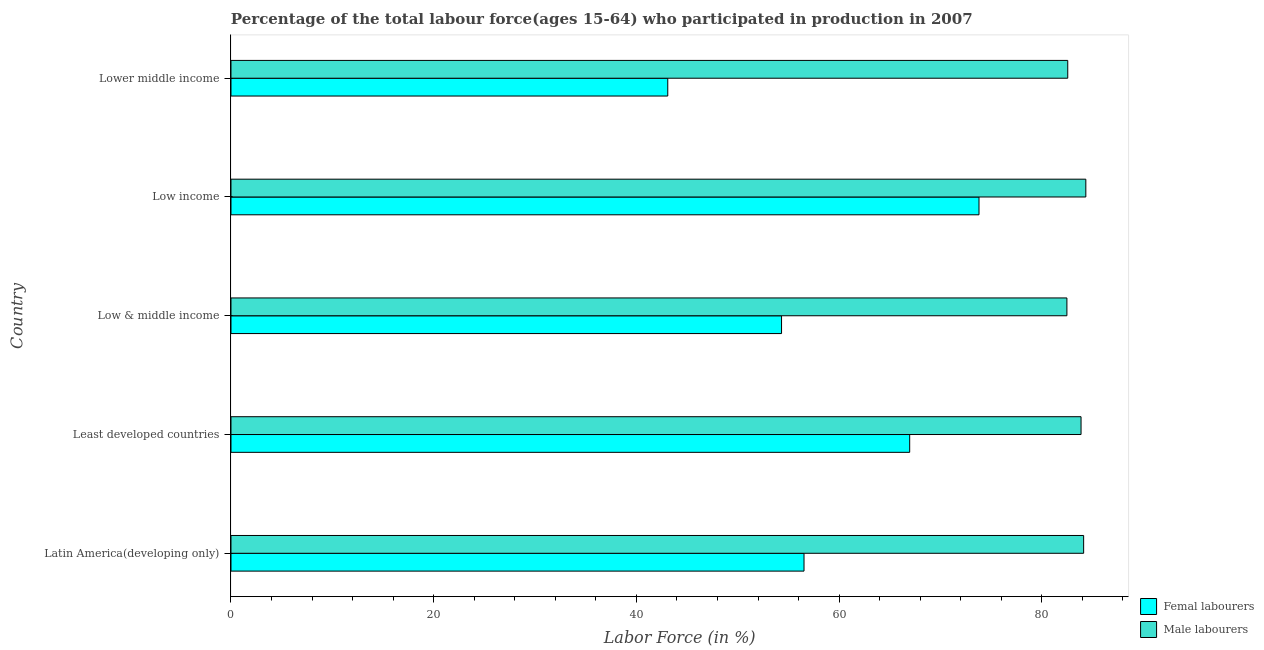How many different coloured bars are there?
Your response must be concise. 2. How many groups of bars are there?
Your response must be concise. 5. Are the number of bars per tick equal to the number of legend labels?
Provide a succinct answer. Yes. Are the number of bars on each tick of the Y-axis equal?
Offer a very short reply. Yes. How many bars are there on the 3rd tick from the bottom?
Offer a terse response. 2. What is the label of the 3rd group of bars from the top?
Your response must be concise. Low & middle income. In how many cases, is the number of bars for a given country not equal to the number of legend labels?
Your answer should be very brief. 0. What is the percentage of female labor force in Lower middle income?
Make the answer very short. 43.1. Across all countries, what is the maximum percentage of male labour force?
Your answer should be very brief. 84.34. Across all countries, what is the minimum percentage of male labour force?
Ensure brevity in your answer.  82.47. In which country was the percentage of female labor force maximum?
Provide a short and direct response. Low income. In which country was the percentage of female labor force minimum?
Offer a very short reply. Lower middle income. What is the total percentage of male labour force in the graph?
Offer a very short reply. 417.37. What is the difference between the percentage of female labor force in Low & middle income and that in Low income?
Your response must be concise. -19.48. What is the difference between the percentage of male labour force in Latin America(developing only) and the percentage of female labor force in Lower middle income?
Ensure brevity in your answer.  41.03. What is the average percentage of male labour force per country?
Your answer should be very brief. 83.47. What is the difference between the percentage of female labor force and percentage of male labour force in Low income?
Make the answer very short. -10.54. What is the ratio of the percentage of female labor force in Latin America(developing only) to that in Least developed countries?
Your answer should be very brief. 0.84. What is the difference between the highest and the second highest percentage of male labour force?
Provide a succinct answer. 0.22. What is the difference between the highest and the lowest percentage of female labor force?
Make the answer very short. 30.71. In how many countries, is the percentage of male labour force greater than the average percentage of male labour force taken over all countries?
Offer a very short reply. 3. Is the sum of the percentage of male labour force in Least developed countries and Low income greater than the maximum percentage of female labor force across all countries?
Keep it short and to the point. Yes. What does the 1st bar from the top in Lower middle income represents?
Your response must be concise. Male labourers. What does the 1st bar from the bottom in Low & middle income represents?
Your answer should be compact. Femal labourers. How many bars are there?
Your answer should be compact. 10. How many countries are there in the graph?
Ensure brevity in your answer.  5. What is the difference between two consecutive major ticks on the X-axis?
Make the answer very short. 20. How many legend labels are there?
Offer a terse response. 2. How are the legend labels stacked?
Ensure brevity in your answer.  Vertical. What is the title of the graph?
Your response must be concise. Percentage of the total labour force(ages 15-64) who participated in production in 2007. Does "Official creditors" appear as one of the legend labels in the graph?
Keep it short and to the point. No. What is the Labor Force (in %) in Femal labourers in Latin America(developing only)?
Your answer should be very brief. 56.54. What is the Labor Force (in %) in Male labourers in Latin America(developing only)?
Give a very brief answer. 84.13. What is the Labor Force (in %) in Femal labourers in Least developed countries?
Offer a very short reply. 66.96. What is the Labor Force (in %) of Male labourers in Least developed countries?
Keep it short and to the point. 83.87. What is the Labor Force (in %) in Femal labourers in Low & middle income?
Keep it short and to the point. 54.32. What is the Labor Force (in %) in Male labourers in Low & middle income?
Your response must be concise. 82.47. What is the Labor Force (in %) of Femal labourers in Low income?
Your response must be concise. 73.8. What is the Labor Force (in %) of Male labourers in Low income?
Ensure brevity in your answer.  84.34. What is the Labor Force (in %) in Femal labourers in Lower middle income?
Ensure brevity in your answer.  43.1. What is the Labor Force (in %) of Male labourers in Lower middle income?
Keep it short and to the point. 82.56. Across all countries, what is the maximum Labor Force (in %) of Femal labourers?
Your response must be concise. 73.8. Across all countries, what is the maximum Labor Force (in %) of Male labourers?
Keep it short and to the point. 84.34. Across all countries, what is the minimum Labor Force (in %) of Femal labourers?
Offer a very short reply. 43.1. Across all countries, what is the minimum Labor Force (in %) of Male labourers?
Your response must be concise. 82.47. What is the total Labor Force (in %) in Femal labourers in the graph?
Your answer should be very brief. 294.72. What is the total Labor Force (in %) in Male labourers in the graph?
Ensure brevity in your answer.  417.37. What is the difference between the Labor Force (in %) in Femal labourers in Latin America(developing only) and that in Least developed countries?
Ensure brevity in your answer.  -10.43. What is the difference between the Labor Force (in %) of Male labourers in Latin America(developing only) and that in Least developed countries?
Provide a succinct answer. 0.26. What is the difference between the Labor Force (in %) in Femal labourers in Latin America(developing only) and that in Low & middle income?
Your answer should be compact. 2.22. What is the difference between the Labor Force (in %) of Male labourers in Latin America(developing only) and that in Low & middle income?
Give a very brief answer. 1.65. What is the difference between the Labor Force (in %) in Femal labourers in Latin America(developing only) and that in Low income?
Offer a very short reply. -17.26. What is the difference between the Labor Force (in %) of Male labourers in Latin America(developing only) and that in Low income?
Ensure brevity in your answer.  -0.22. What is the difference between the Labor Force (in %) in Femal labourers in Latin America(developing only) and that in Lower middle income?
Provide a short and direct response. 13.44. What is the difference between the Labor Force (in %) of Male labourers in Latin America(developing only) and that in Lower middle income?
Offer a very short reply. 1.57. What is the difference between the Labor Force (in %) in Femal labourers in Least developed countries and that in Low & middle income?
Keep it short and to the point. 12.64. What is the difference between the Labor Force (in %) in Male labourers in Least developed countries and that in Low & middle income?
Your response must be concise. 1.4. What is the difference between the Labor Force (in %) of Femal labourers in Least developed countries and that in Low income?
Provide a short and direct response. -6.84. What is the difference between the Labor Force (in %) of Male labourers in Least developed countries and that in Low income?
Give a very brief answer. -0.47. What is the difference between the Labor Force (in %) of Femal labourers in Least developed countries and that in Lower middle income?
Give a very brief answer. 23.87. What is the difference between the Labor Force (in %) of Male labourers in Least developed countries and that in Lower middle income?
Give a very brief answer. 1.31. What is the difference between the Labor Force (in %) of Femal labourers in Low & middle income and that in Low income?
Give a very brief answer. -19.48. What is the difference between the Labor Force (in %) of Male labourers in Low & middle income and that in Low income?
Ensure brevity in your answer.  -1.87. What is the difference between the Labor Force (in %) in Femal labourers in Low & middle income and that in Lower middle income?
Keep it short and to the point. 11.22. What is the difference between the Labor Force (in %) in Male labourers in Low & middle income and that in Lower middle income?
Give a very brief answer. -0.08. What is the difference between the Labor Force (in %) of Femal labourers in Low income and that in Lower middle income?
Give a very brief answer. 30.71. What is the difference between the Labor Force (in %) in Male labourers in Low income and that in Lower middle income?
Keep it short and to the point. 1.78. What is the difference between the Labor Force (in %) of Femal labourers in Latin America(developing only) and the Labor Force (in %) of Male labourers in Least developed countries?
Keep it short and to the point. -27.33. What is the difference between the Labor Force (in %) of Femal labourers in Latin America(developing only) and the Labor Force (in %) of Male labourers in Low & middle income?
Provide a short and direct response. -25.94. What is the difference between the Labor Force (in %) in Femal labourers in Latin America(developing only) and the Labor Force (in %) in Male labourers in Low income?
Your answer should be very brief. -27.8. What is the difference between the Labor Force (in %) of Femal labourers in Latin America(developing only) and the Labor Force (in %) of Male labourers in Lower middle income?
Your answer should be compact. -26.02. What is the difference between the Labor Force (in %) in Femal labourers in Least developed countries and the Labor Force (in %) in Male labourers in Low & middle income?
Give a very brief answer. -15.51. What is the difference between the Labor Force (in %) of Femal labourers in Least developed countries and the Labor Force (in %) of Male labourers in Low income?
Ensure brevity in your answer.  -17.38. What is the difference between the Labor Force (in %) in Femal labourers in Least developed countries and the Labor Force (in %) in Male labourers in Lower middle income?
Your answer should be compact. -15.59. What is the difference between the Labor Force (in %) in Femal labourers in Low & middle income and the Labor Force (in %) in Male labourers in Low income?
Give a very brief answer. -30.02. What is the difference between the Labor Force (in %) in Femal labourers in Low & middle income and the Labor Force (in %) in Male labourers in Lower middle income?
Offer a very short reply. -28.24. What is the difference between the Labor Force (in %) in Femal labourers in Low income and the Labor Force (in %) in Male labourers in Lower middle income?
Ensure brevity in your answer.  -8.76. What is the average Labor Force (in %) in Femal labourers per country?
Offer a very short reply. 58.94. What is the average Labor Force (in %) of Male labourers per country?
Ensure brevity in your answer.  83.47. What is the difference between the Labor Force (in %) in Femal labourers and Labor Force (in %) in Male labourers in Latin America(developing only)?
Your answer should be very brief. -27.59. What is the difference between the Labor Force (in %) in Femal labourers and Labor Force (in %) in Male labourers in Least developed countries?
Keep it short and to the point. -16.91. What is the difference between the Labor Force (in %) in Femal labourers and Labor Force (in %) in Male labourers in Low & middle income?
Give a very brief answer. -28.15. What is the difference between the Labor Force (in %) in Femal labourers and Labor Force (in %) in Male labourers in Low income?
Your answer should be compact. -10.54. What is the difference between the Labor Force (in %) of Femal labourers and Labor Force (in %) of Male labourers in Lower middle income?
Make the answer very short. -39.46. What is the ratio of the Labor Force (in %) of Femal labourers in Latin America(developing only) to that in Least developed countries?
Give a very brief answer. 0.84. What is the ratio of the Labor Force (in %) in Male labourers in Latin America(developing only) to that in Least developed countries?
Your answer should be compact. 1. What is the ratio of the Labor Force (in %) of Femal labourers in Latin America(developing only) to that in Low & middle income?
Offer a very short reply. 1.04. What is the ratio of the Labor Force (in %) of Femal labourers in Latin America(developing only) to that in Low income?
Give a very brief answer. 0.77. What is the ratio of the Labor Force (in %) of Male labourers in Latin America(developing only) to that in Low income?
Offer a terse response. 1. What is the ratio of the Labor Force (in %) of Femal labourers in Latin America(developing only) to that in Lower middle income?
Keep it short and to the point. 1.31. What is the ratio of the Labor Force (in %) of Male labourers in Latin America(developing only) to that in Lower middle income?
Give a very brief answer. 1.02. What is the ratio of the Labor Force (in %) of Femal labourers in Least developed countries to that in Low & middle income?
Your response must be concise. 1.23. What is the ratio of the Labor Force (in %) in Male labourers in Least developed countries to that in Low & middle income?
Keep it short and to the point. 1.02. What is the ratio of the Labor Force (in %) in Femal labourers in Least developed countries to that in Low income?
Make the answer very short. 0.91. What is the ratio of the Labor Force (in %) in Male labourers in Least developed countries to that in Low income?
Make the answer very short. 0.99. What is the ratio of the Labor Force (in %) in Femal labourers in Least developed countries to that in Lower middle income?
Your response must be concise. 1.55. What is the ratio of the Labor Force (in %) of Male labourers in Least developed countries to that in Lower middle income?
Provide a succinct answer. 1.02. What is the ratio of the Labor Force (in %) in Femal labourers in Low & middle income to that in Low income?
Give a very brief answer. 0.74. What is the ratio of the Labor Force (in %) in Male labourers in Low & middle income to that in Low income?
Your answer should be compact. 0.98. What is the ratio of the Labor Force (in %) in Femal labourers in Low & middle income to that in Lower middle income?
Offer a terse response. 1.26. What is the ratio of the Labor Force (in %) of Male labourers in Low & middle income to that in Lower middle income?
Offer a terse response. 1. What is the ratio of the Labor Force (in %) of Femal labourers in Low income to that in Lower middle income?
Provide a succinct answer. 1.71. What is the ratio of the Labor Force (in %) in Male labourers in Low income to that in Lower middle income?
Give a very brief answer. 1.02. What is the difference between the highest and the second highest Labor Force (in %) in Femal labourers?
Your answer should be very brief. 6.84. What is the difference between the highest and the second highest Labor Force (in %) in Male labourers?
Your answer should be compact. 0.22. What is the difference between the highest and the lowest Labor Force (in %) in Femal labourers?
Offer a terse response. 30.71. What is the difference between the highest and the lowest Labor Force (in %) in Male labourers?
Your answer should be very brief. 1.87. 